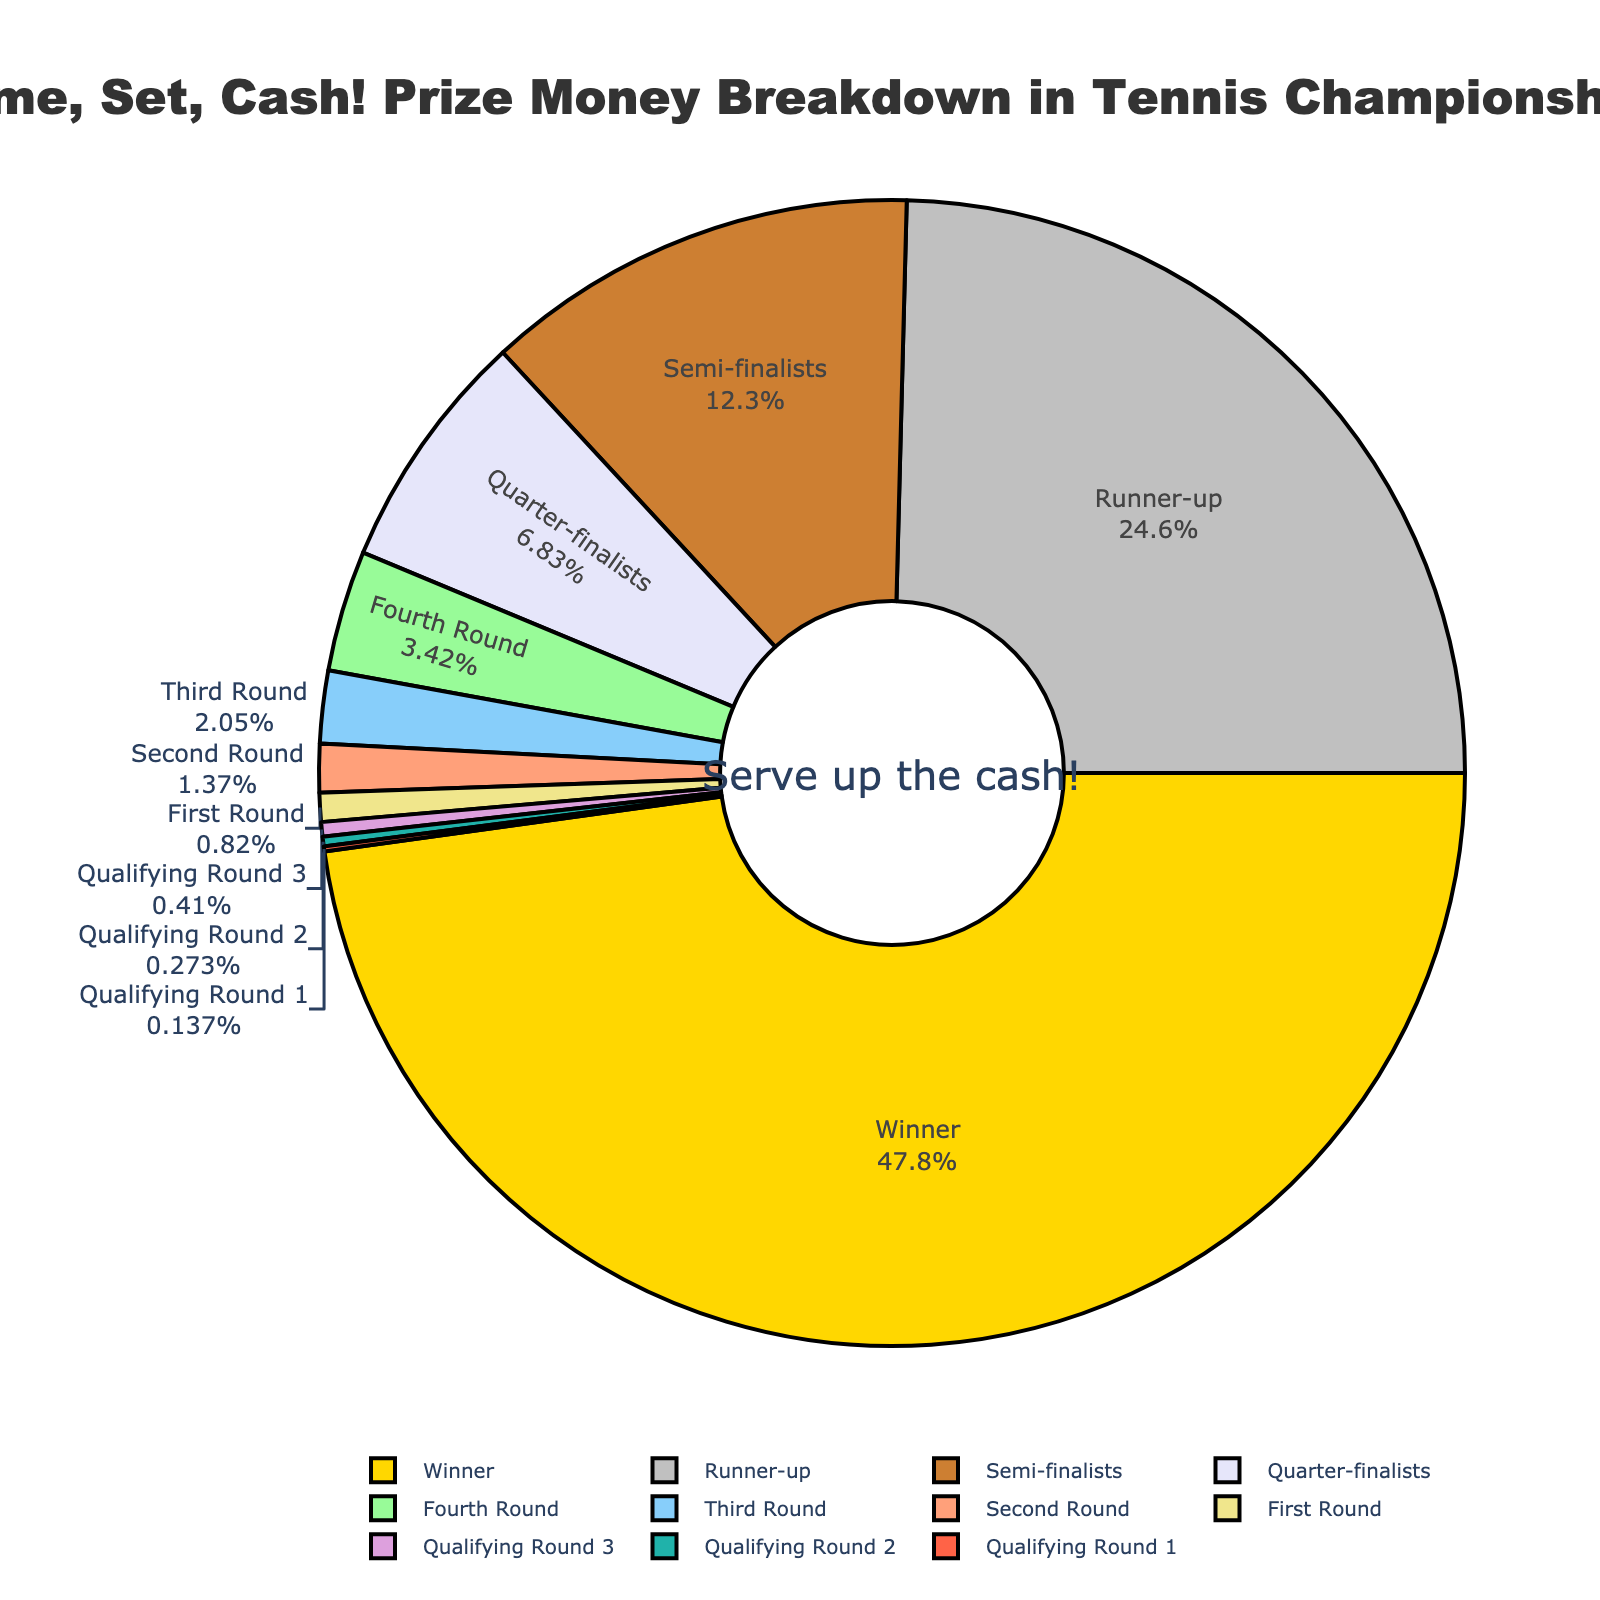Which round gets the highest percentage of prize money? The figure shows a pie chart with different segments representing the prize money allocated to each round. The segment labeled "Winner" is the largest and occupies 35% of the chart.
Answer: Winner What is the combined percentage of prize money for the Semi-finalists and Quarter-finalists? From the pie chart, the Semi-finalists receive 9% each and the Quarter-finalists receive another 5%. Adding these together: 9% + 9% + 5% = 23%.
Answer: 23% How much more prize money percentage does the Runner-up get compared to the Fourth Round? The Runner-up receives 18% of the prize money, while the Fourth Round receives 2.5%. Subtract the percentage of the Fourth Round from the Runner-up: 18% - 2.5% = 15.5%.
Answer: 15.5% Which rounds, when combined, make up exactly 2.1% of the prize money? The pie chart shows the Third Round with 1.5%, Second Round with 1%, and Qualifying Round 1 with 0.1%. Adding the Second Round (1%) and Qualifying Round 3 (0.3%) gives 1% + 0.3% = 1.3%, which doesn't fit. Combining the Third Round (1.5%) and Qualifying Round 1 (0.1%) and Qualifying Round 2 (0.2%) gives 1.5% + 0.1% + 0.2% = 1.8%, still not exactly 2.1%. Combining Second Round (1%) and Third Round (1.5%) does not meet exactly 2.1%. Instead, combine Second Round (1%) with Qualifying Round 3 (0.3%), and Third Round (1.5%) provides 1% + 0.3% + 1.5%= 2.8%, thus this also doesn't meet the exact specific value.  Therefore, none fit exactly 2.1%, but close fits include combinations 2.8% composition.
Answer: None fit exactly How much more prize money percentage do the Semi-finalists and Quarter-finalists receive together compared to the Second Round and Third Round combined? The Semi-finalists receive 9% each, which when doubled = 18%. The Quarter-finalists receive 5%, for a total of 18% + 5% = 23%. The Second Round receives 1% and the Third Round receives 1.5%, totaling 1% + 1.5% = 2.5%. Take the difference: 23% - 2.5% = 20.5%.
Answer: 20.5% If a player reaches the Second Round, how much higher would their prize money percentage be if they made it to the Third Round instead? The Second Round accounts for 1% of the prize money, while the Third Round accounts for 1.5%. The difference is thus 1.5% - 1% = 0.5%.
Answer: 0.5% Which rounds together account for less than 1% of the prize money? The pie chart clearly shows the percentages: Qualifying Round 1 (0.1%), Qualifying Round 2 (0.2%), and Qualifying Round 3 (0.3%). Adding these: 0.1% + 0.2% + 0.3% = 0.6% which is less than 1%.
Answer: Qualifying Round 1, Qualifying Round 2, Qualifying Round 3 